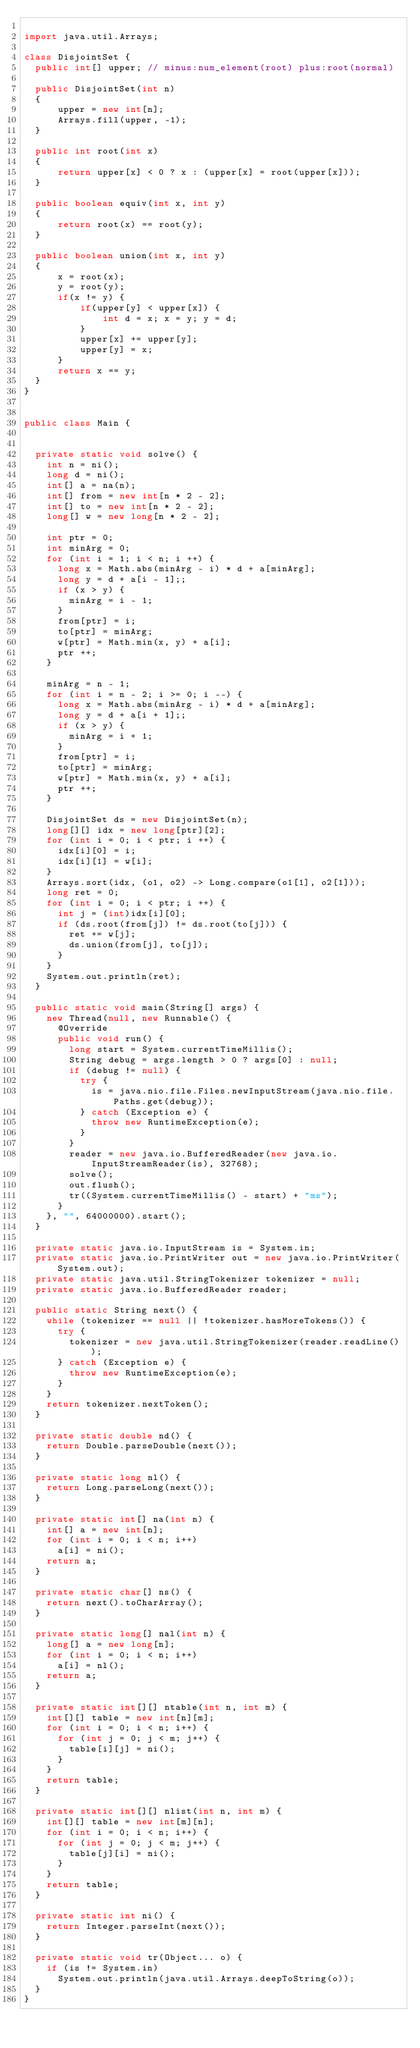<code> <loc_0><loc_0><loc_500><loc_500><_Java_>
import java.util.Arrays;

class DisjointSet {
  public int[] upper; // minus:num_element(root) plus:root(normal)
  
  public DisjointSet(int n)
  {
      upper = new int[n];
      Arrays.fill(upper, -1);
  }
  
  public int root(int x)
  {
      return upper[x] < 0 ? x : (upper[x] = root(upper[x]));
  }
  
  public boolean equiv(int x, int y)
  {
      return root(x) == root(y);
  }
  
  public boolean union(int x, int y)
  {
      x = root(x);
      y = root(y);
      if(x != y) {
          if(upper[y] < upper[x]) {
              int d = x; x = y; y = d;
          }
          upper[x] += upper[y];
          upper[y] = x;
      }
      return x == y;
  }
}


public class Main {


  private static void solve() {
    int n = ni();
    long d = ni();
    int[] a = na(n);
    int[] from = new int[n * 2 - 2];
    int[] to = new int[n * 2 - 2];
    long[] w = new long[n * 2 - 2];
    
    int ptr = 0;
    int minArg = 0;
    for (int i = 1; i < n; i ++) {
      long x = Math.abs(minArg - i) * d + a[minArg];
      long y = d + a[i - 1];;
      if (x > y) {
        minArg = i - 1;
      }
      from[ptr] = i;
      to[ptr] = minArg;
      w[ptr] = Math.min(x, y) + a[i];
      ptr ++;
    }
    
    minArg = n - 1;
    for (int i = n - 2; i >= 0; i --) {
      long x = Math.abs(minArg - i) * d + a[minArg];
      long y = d + a[i + 1];;
      if (x > y) {
        minArg = i + 1;
      }
      from[ptr] = i;
      to[ptr] = minArg;
      w[ptr] = Math.min(x, y) + a[i];
      ptr ++;
    }
    
    DisjointSet ds = new DisjointSet(n);
    long[][] idx = new long[ptr][2];
    for (int i = 0; i < ptr; i ++) {
      idx[i][0] = i;
      idx[i][1] = w[i];
    }
    Arrays.sort(idx, (o1, o2) -> Long.compare(o1[1], o2[1]));
    long ret = 0;
    for (int i = 0; i < ptr; i ++) {
      int j = (int)idx[i][0];
      if (ds.root(from[j]) != ds.root(to[j])) {
        ret += w[j];
        ds.union(from[j], to[j]);
      }
    }
    System.out.println(ret);
  }

  public static void main(String[] args) {
    new Thread(null, new Runnable() {
      @Override
      public void run() {
        long start = System.currentTimeMillis();
        String debug = args.length > 0 ? args[0] : null;
        if (debug != null) {
          try {
            is = java.nio.file.Files.newInputStream(java.nio.file.Paths.get(debug));
          } catch (Exception e) {
            throw new RuntimeException(e);
          }
        }
        reader = new java.io.BufferedReader(new java.io.InputStreamReader(is), 32768);
        solve();
        out.flush();
        tr((System.currentTimeMillis() - start) + "ms");
      }
    }, "", 64000000).start();
  }

  private static java.io.InputStream is = System.in;
  private static java.io.PrintWriter out = new java.io.PrintWriter(System.out);
  private static java.util.StringTokenizer tokenizer = null;
  private static java.io.BufferedReader reader;

  public static String next() {
    while (tokenizer == null || !tokenizer.hasMoreTokens()) {
      try {
        tokenizer = new java.util.StringTokenizer(reader.readLine());
      } catch (Exception e) {
        throw new RuntimeException(e);
      }
    }
    return tokenizer.nextToken();
  }

  private static double nd() {
    return Double.parseDouble(next());
  }

  private static long nl() {
    return Long.parseLong(next());
  }

  private static int[] na(int n) {
    int[] a = new int[n];
    for (int i = 0; i < n; i++)
      a[i] = ni();
    return a;
  }

  private static char[] ns() {
    return next().toCharArray();
  }

  private static long[] nal(int n) {
    long[] a = new long[n];
    for (int i = 0; i < n; i++)
      a[i] = nl();
    return a;
  }

  private static int[][] ntable(int n, int m) {
    int[][] table = new int[n][m];
    for (int i = 0; i < n; i++) {
      for (int j = 0; j < m; j++) {
        table[i][j] = ni();
      }
    }
    return table;
  }

  private static int[][] nlist(int n, int m) {
    int[][] table = new int[m][n];
    for (int i = 0; i < n; i++) {
      for (int j = 0; j < m; j++) {
        table[j][i] = ni();
      }
    }
    return table;
  }

  private static int ni() {
    return Integer.parseInt(next());
  }

  private static void tr(Object... o) {
    if (is != System.in)
      System.out.println(java.util.Arrays.deepToString(o));
  }
}
</code> 